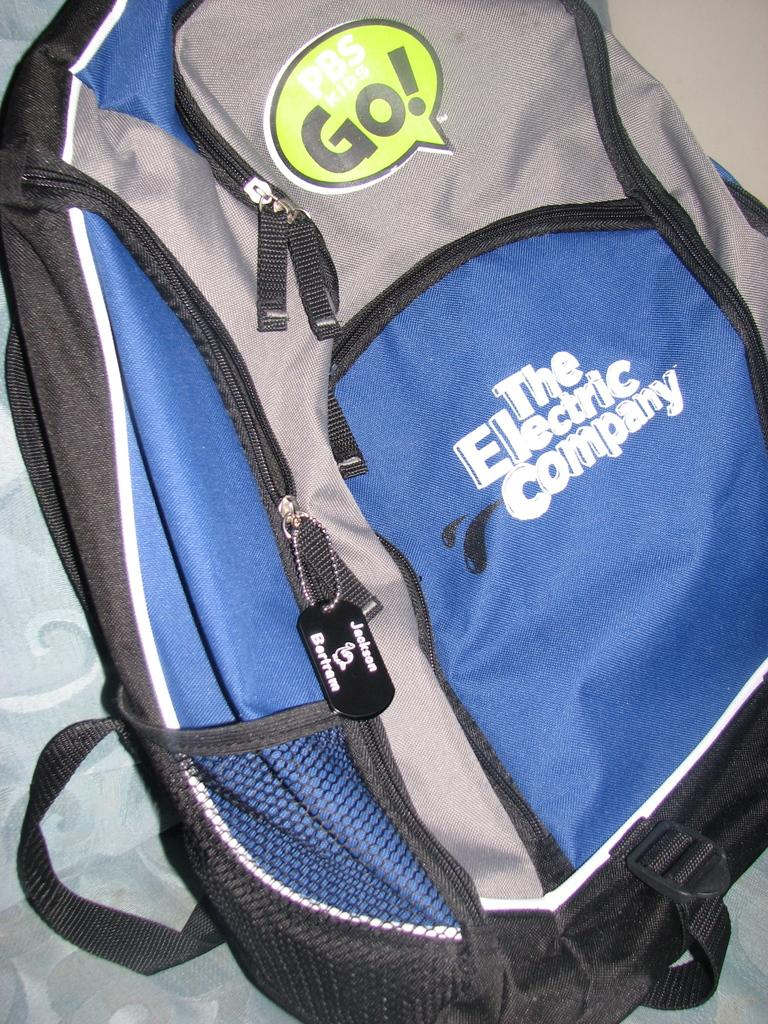Provide a one-sentence caption for the provided image. A gray, black and blue backpack with the words The Electric Company printed on it. 